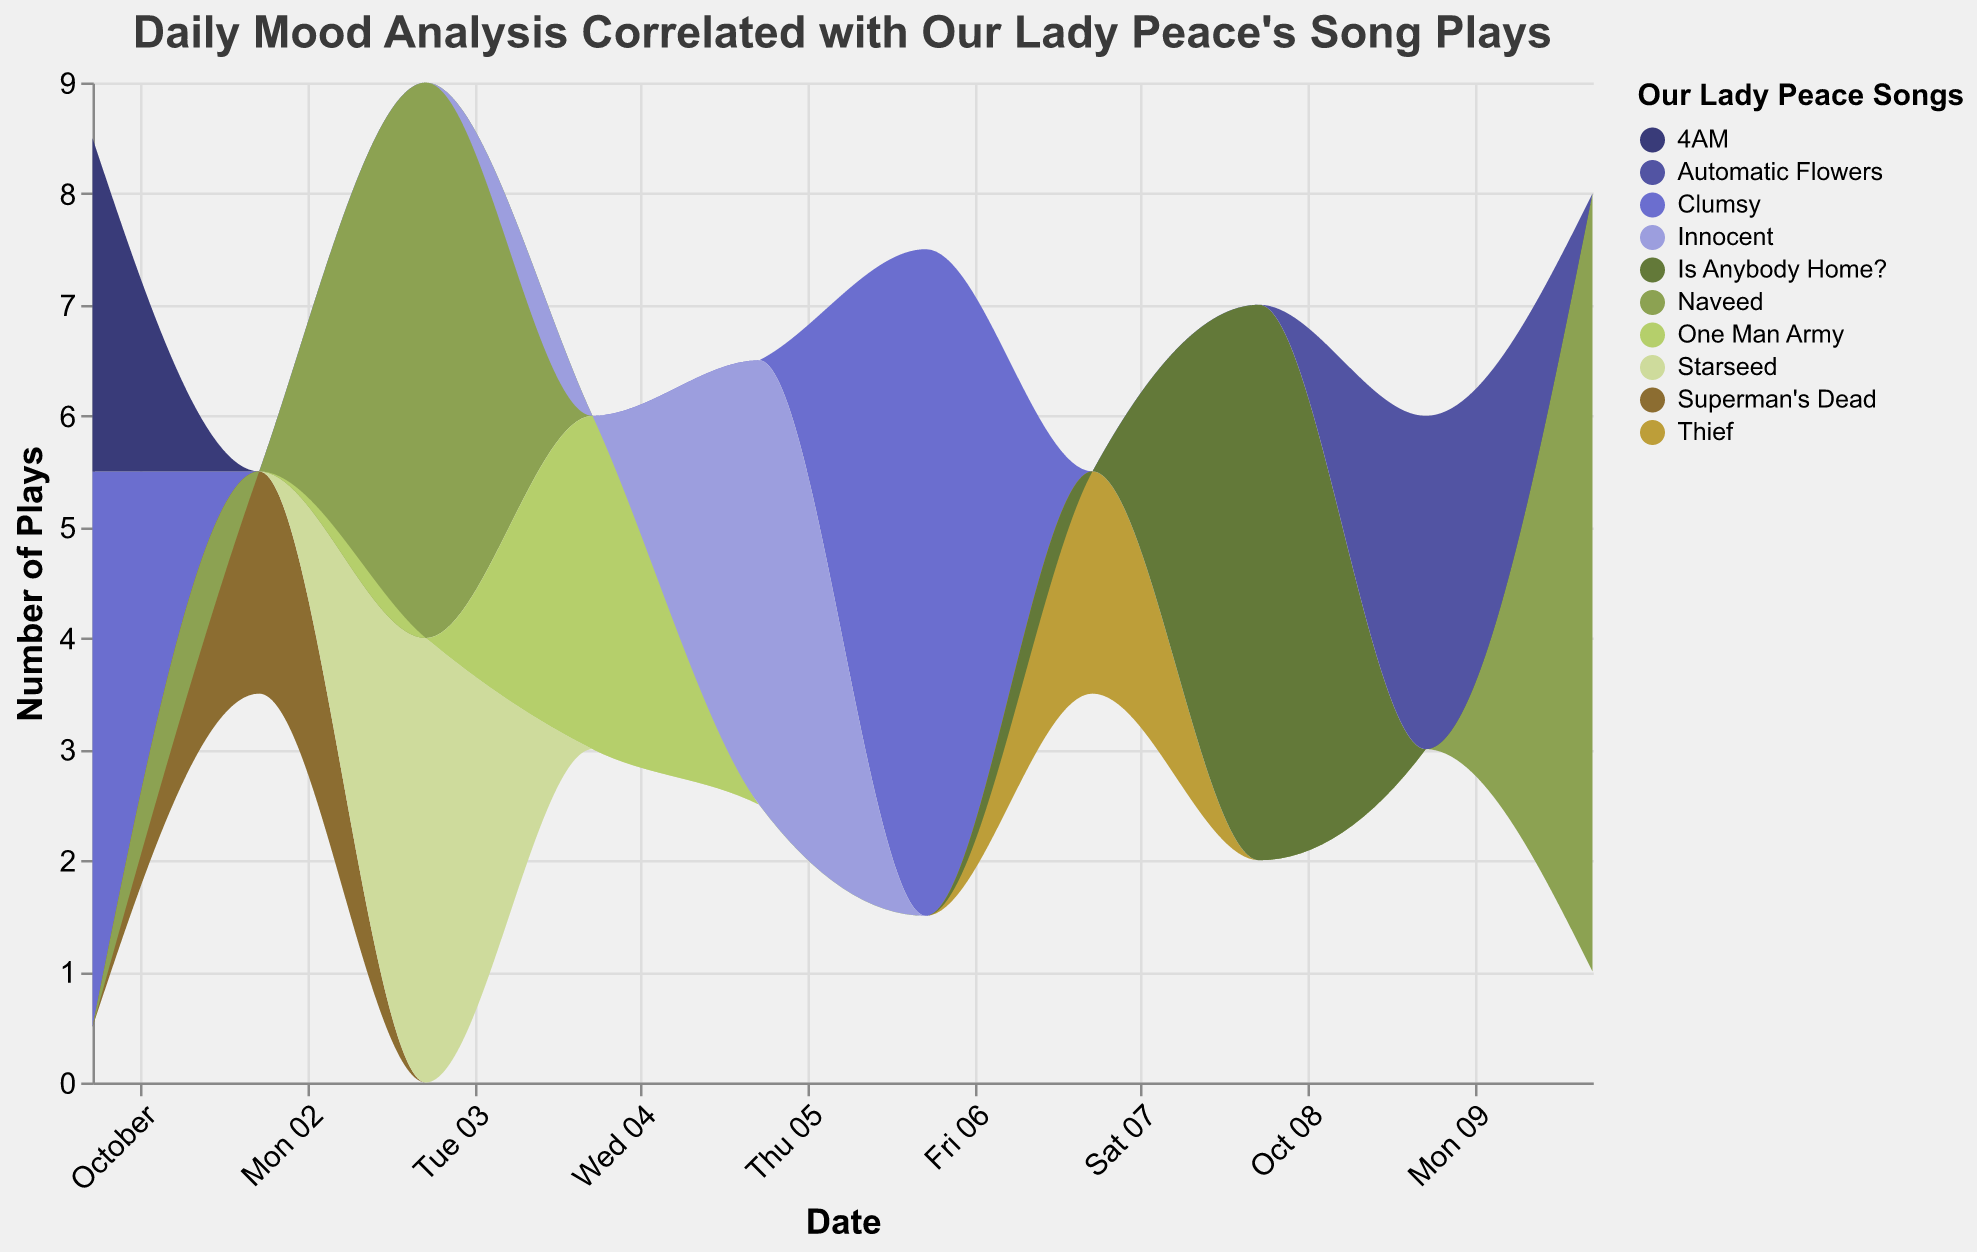What is the title of the graph? The title of the graph is usually located at the top of the figure. From the provided information, the title is "Daily Mood Analysis Correlated with Our Lady Peace's Song Plays".
Answer: Daily Mood Analysis Correlated with Our Lady Peace's Song Plays Which song was played the most on October 10th? Look for the section corresponding to October 10th on the x-axis and check which stack in the stream graph has the highest value. According to the data, "Naveed" had 7 plays on October 10th.
Answer: Naveed How many different songs are represented in the graph? The 'Song' field appears in the legend of the graph. By counting the unique entries in the legend, one can determine the number of different songs. Based on the data, there are 10 unique songs.
Answer: 10 On which date was the highest number of "Clumsy" plays, and how many were there? Identify the section in the graph where "Clumsy" (color in the legend) has the highest peak. According to the data, the highest plays for "Clumsy" were 6 on October 6th.
Answer: October 6th, 6 Which mood is associated with the highest plays of the song "Is Anybody Home?" and how many plays were there? Find the song "Is Anybody Home?" in the stream graph. By checking associated moods, the data indicates "Joyful" is correlated with the highest plays (5) on October 8th.
Answer: Joyful, 5 What is the average number of plays for the song "Naveed"? Look up the data points corresponding to "Naveed" and sum the plays, then divide by the number of occurrences. The plays for "Naveed" are 5 (Oct 3) and 7 (Oct 10), so the average is (5 + 7) / 2.
Answer: 6 Which two dates had the same number of plays for different songs, and what were the songs? Compare different dates in the graph to identify any with matching play counts for different songs. According to the data, on October 1, "Clumsy" had 5 plays and "Naveed" also had 5 plays on October 3.
Answer: October 1 (Clumsy), October 3 (Naveed) How does the mood of "Happy" correlate with song plays over the given dates? Examine the stream representing the "Happy" mood and note its trends. According to the data, "Happy" correlates with "Clumsy" on October 1 and 6, and "Naveed" on October 3 and 10.
Answer: It fluctuates but generally corresponds to high play counts on specific dates Which song had the lowest number of plays and on which date? Locate the streams with the smallest heights. According to the data, "Superman's Dead" had the lowest number of plays (2) on October 2.
Answer: Superman's Dead, October 2 Comparing "Happy" and "Sad" moods, which had more song plays on October 1st? Check the data for October 1st and compare the total plays for "Happy" (5 for "Clumsy") and "Sad" (3 for "4AM"). "Happy" had more plays.
Answer: Happy, 5 plays 